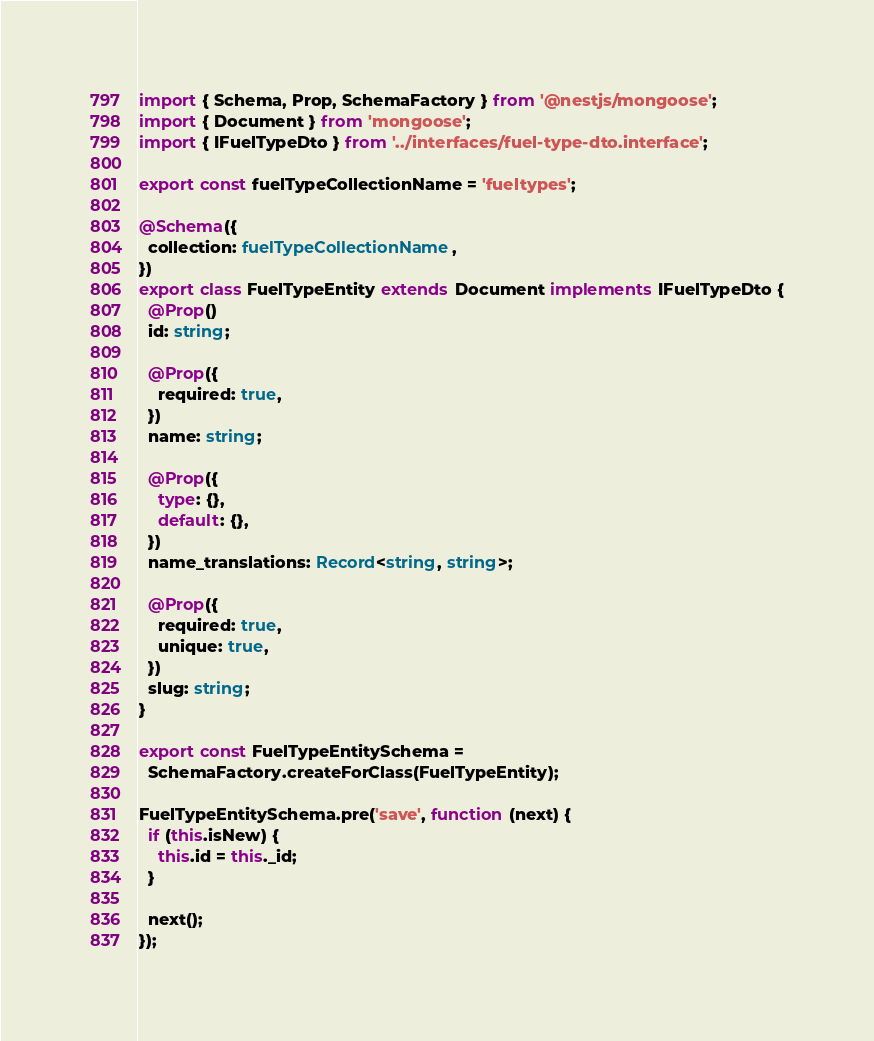<code> <loc_0><loc_0><loc_500><loc_500><_TypeScript_>import { Schema, Prop, SchemaFactory } from '@nestjs/mongoose';
import { Document } from 'mongoose';
import { IFuelTypeDto } from '../interfaces/fuel-type-dto.interface';

export const fuelTypeCollectionName = 'fueltypes';

@Schema({
  collection: fuelTypeCollectionName,
})
export class FuelTypeEntity extends Document implements IFuelTypeDto {
  @Prop()
  id: string;

  @Prop({
    required: true,
  })
  name: string;

  @Prop({
    type: {},
    default: {},
  })
  name_translations: Record<string, string>;

  @Prop({
    required: true,
    unique: true,
  })
  slug: string;
}

export const FuelTypeEntitySchema =
  SchemaFactory.createForClass(FuelTypeEntity);

FuelTypeEntitySchema.pre('save', function (next) {
  if (this.isNew) {
    this.id = this._id;
  }

  next();
});
</code> 